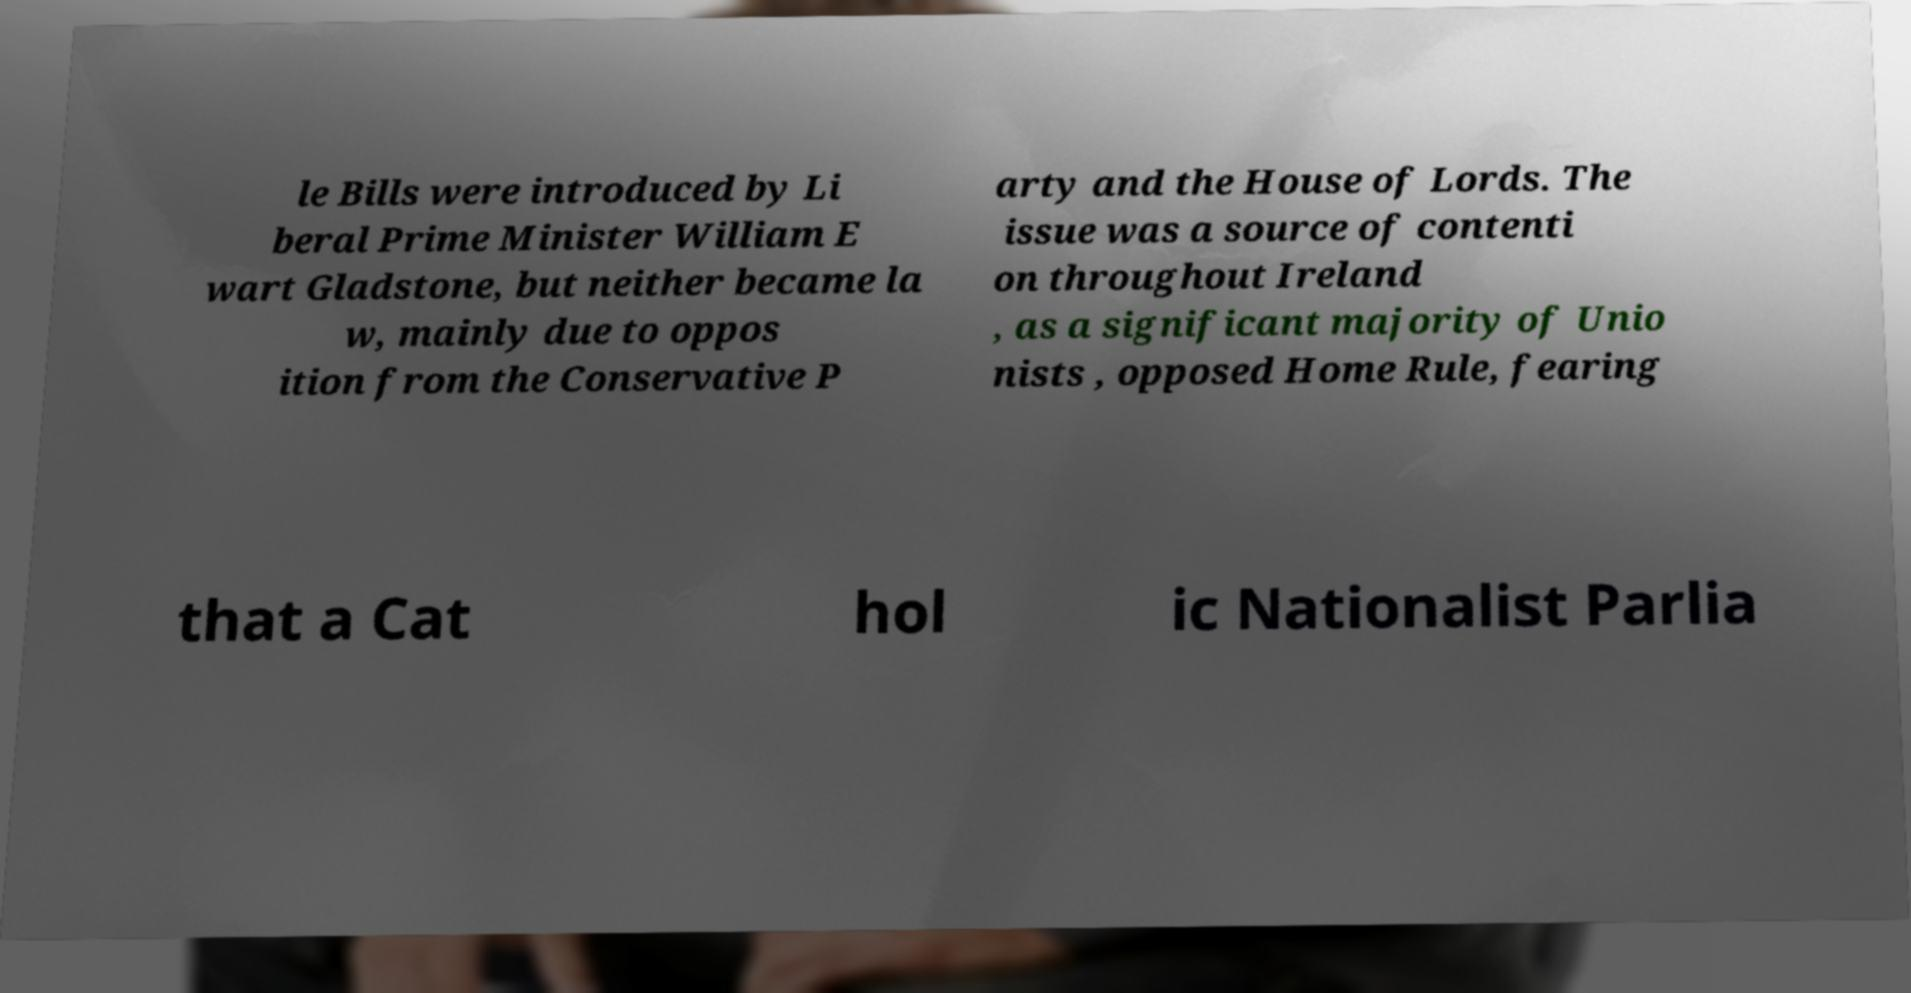There's text embedded in this image that I need extracted. Can you transcribe it verbatim? le Bills were introduced by Li beral Prime Minister William E wart Gladstone, but neither became la w, mainly due to oppos ition from the Conservative P arty and the House of Lords. The issue was a source of contenti on throughout Ireland , as a significant majority of Unio nists , opposed Home Rule, fearing that a Cat hol ic Nationalist Parlia 